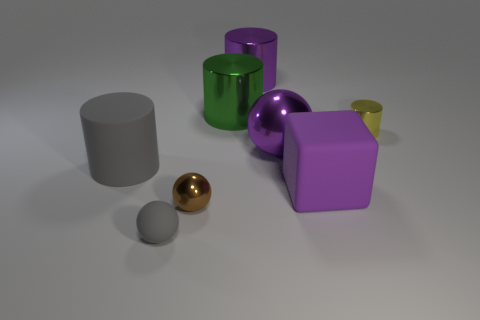What number of objects are either large purple objects that are in front of the tiny yellow cylinder or small yellow metal cylinders?
Ensure brevity in your answer.  3. Is the tiny yellow cylinder made of the same material as the purple cylinder?
Make the answer very short. Yes. What is the size of the gray thing that is the same shape as the tiny yellow object?
Keep it short and to the point. Large. There is a big purple thing that is on the right side of the large purple sphere; is it the same shape as the tiny metallic object that is on the left side of the large green thing?
Give a very brief answer. No. Do the green shiny thing and the rubber thing left of the tiny gray matte sphere have the same size?
Give a very brief answer. Yes. How many other objects are there of the same material as the large green cylinder?
Offer a very short reply. 4. Are there any other things that have the same shape as the small matte thing?
Provide a short and direct response. Yes. There is a small metal object on the left side of the sphere on the right side of the small shiny thing that is in front of the big purple block; what color is it?
Give a very brief answer. Brown. What is the shape of the object that is both in front of the large matte cylinder and right of the brown metal ball?
Your answer should be very brief. Cube. There is a big thing that is to the left of the gray object in front of the tiny brown metal sphere; what is its color?
Your response must be concise. Gray. 